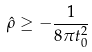Convert formula to latex. <formula><loc_0><loc_0><loc_500><loc_500>\hat { \rho } \geq - \frac { 1 } { 8 \pi t _ { 0 } ^ { 2 } }</formula> 